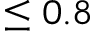Convert formula to latex. <formula><loc_0><loc_0><loc_500><loc_500>\leq 0 . 8</formula> 